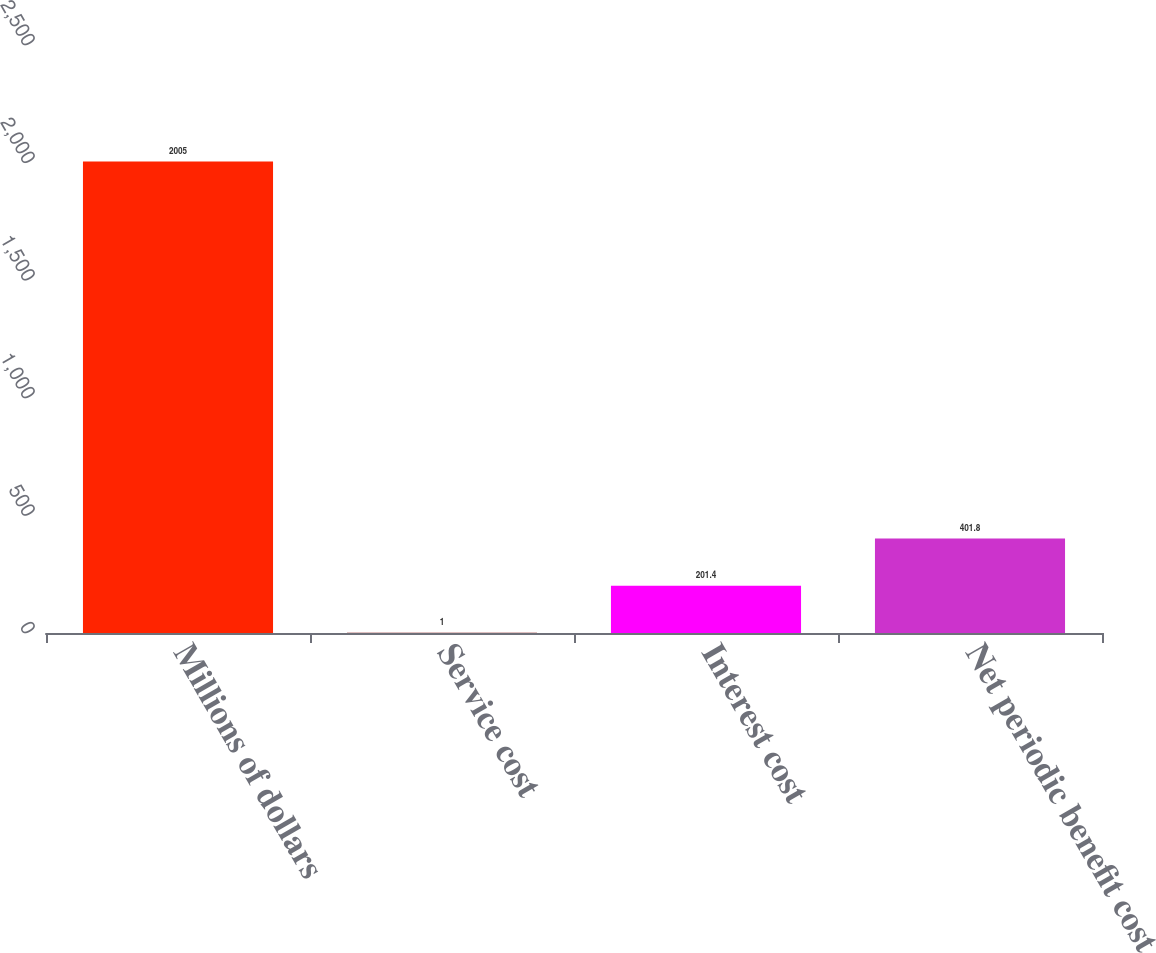<chart> <loc_0><loc_0><loc_500><loc_500><bar_chart><fcel>Millions of dollars<fcel>Service cost<fcel>Interest cost<fcel>Net periodic benefit cost<nl><fcel>2005<fcel>1<fcel>201.4<fcel>401.8<nl></chart> 